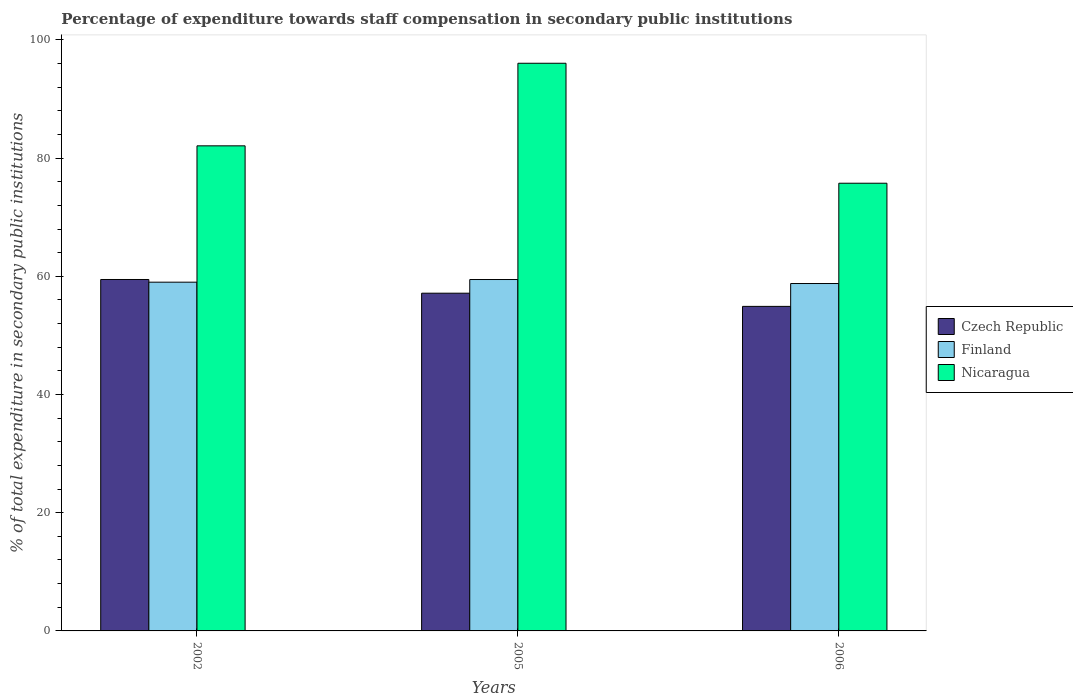How many different coloured bars are there?
Offer a terse response. 3. How many groups of bars are there?
Offer a very short reply. 3. Are the number of bars per tick equal to the number of legend labels?
Your answer should be compact. Yes. In how many cases, is the number of bars for a given year not equal to the number of legend labels?
Give a very brief answer. 0. What is the percentage of expenditure towards staff compensation in Nicaragua in 2005?
Provide a short and direct response. 96.04. Across all years, what is the maximum percentage of expenditure towards staff compensation in Nicaragua?
Ensure brevity in your answer.  96.04. Across all years, what is the minimum percentage of expenditure towards staff compensation in Czech Republic?
Keep it short and to the point. 54.91. In which year was the percentage of expenditure towards staff compensation in Czech Republic maximum?
Provide a short and direct response. 2002. In which year was the percentage of expenditure towards staff compensation in Nicaragua minimum?
Provide a short and direct response. 2006. What is the total percentage of expenditure towards staff compensation in Nicaragua in the graph?
Make the answer very short. 253.86. What is the difference between the percentage of expenditure towards staff compensation in Nicaragua in 2005 and that in 2006?
Make the answer very short. 20.3. What is the difference between the percentage of expenditure towards staff compensation in Finland in 2005 and the percentage of expenditure towards staff compensation in Czech Republic in 2002?
Your answer should be very brief. -0. What is the average percentage of expenditure towards staff compensation in Czech Republic per year?
Give a very brief answer. 57.17. In the year 2005, what is the difference between the percentage of expenditure towards staff compensation in Czech Republic and percentage of expenditure towards staff compensation in Finland?
Ensure brevity in your answer.  -2.31. What is the ratio of the percentage of expenditure towards staff compensation in Nicaragua in 2005 to that in 2006?
Your answer should be compact. 1.27. What is the difference between the highest and the second highest percentage of expenditure towards staff compensation in Finland?
Offer a terse response. 0.45. What is the difference between the highest and the lowest percentage of expenditure towards staff compensation in Finland?
Offer a terse response. 0.68. Is the sum of the percentage of expenditure towards staff compensation in Nicaragua in 2002 and 2006 greater than the maximum percentage of expenditure towards staff compensation in Finland across all years?
Offer a very short reply. Yes. Is it the case that in every year, the sum of the percentage of expenditure towards staff compensation in Nicaragua and percentage of expenditure towards staff compensation in Czech Republic is greater than the percentage of expenditure towards staff compensation in Finland?
Ensure brevity in your answer.  Yes. How many bars are there?
Keep it short and to the point. 9. Are all the bars in the graph horizontal?
Your response must be concise. No. How many years are there in the graph?
Give a very brief answer. 3. Are the values on the major ticks of Y-axis written in scientific E-notation?
Provide a succinct answer. No. Does the graph contain any zero values?
Your response must be concise. No. Where does the legend appear in the graph?
Your response must be concise. Center right. How are the legend labels stacked?
Ensure brevity in your answer.  Vertical. What is the title of the graph?
Ensure brevity in your answer.  Percentage of expenditure towards staff compensation in secondary public institutions. Does "Middle East & North Africa (developing only)" appear as one of the legend labels in the graph?
Make the answer very short. No. What is the label or title of the Y-axis?
Your answer should be compact. % of total expenditure in secondary public institutions. What is the % of total expenditure in secondary public institutions in Czech Republic in 2002?
Give a very brief answer. 59.46. What is the % of total expenditure in secondary public institutions of Finland in 2002?
Offer a very short reply. 59. What is the % of total expenditure in secondary public institutions of Nicaragua in 2002?
Provide a short and direct response. 82.07. What is the % of total expenditure in secondary public institutions of Czech Republic in 2005?
Your response must be concise. 57.14. What is the % of total expenditure in secondary public institutions in Finland in 2005?
Your answer should be compact. 59.45. What is the % of total expenditure in secondary public institutions of Nicaragua in 2005?
Give a very brief answer. 96.04. What is the % of total expenditure in secondary public institutions of Czech Republic in 2006?
Keep it short and to the point. 54.91. What is the % of total expenditure in secondary public institutions in Finland in 2006?
Offer a terse response. 58.78. What is the % of total expenditure in secondary public institutions of Nicaragua in 2006?
Offer a very short reply. 75.75. Across all years, what is the maximum % of total expenditure in secondary public institutions in Czech Republic?
Offer a very short reply. 59.46. Across all years, what is the maximum % of total expenditure in secondary public institutions of Finland?
Offer a terse response. 59.45. Across all years, what is the maximum % of total expenditure in secondary public institutions in Nicaragua?
Offer a terse response. 96.04. Across all years, what is the minimum % of total expenditure in secondary public institutions in Czech Republic?
Your response must be concise. 54.91. Across all years, what is the minimum % of total expenditure in secondary public institutions of Finland?
Keep it short and to the point. 58.78. Across all years, what is the minimum % of total expenditure in secondary public institutions of Nicaragua?
Your answer should be very brief. 75.75. What is the total % of total expenditure in secondary public institutions in Czech Republic in the graph?
Make the answer very short. 171.51. What is the total % of total expenditure in secondary public institutions in Finland in the graph?
Make the answer very short. 177.24. What is the total % of total expenditure in secondary public institutions of Nicaragua in the graph?
Your answer should be very brief. 253.86. What is the difference between the % of total expenditure in secondary public institutions in Czech Republic in 2002 and that in 2005?
Your answer should be compact. 2.32. What is the difference between the % of total expenditure in secondary public institutions of Finland in 2002 and that in 2005?
Offer a terse response. -0.45. What is the difference between the % of total expenditure in secondary public institutions of Nicaragua in 2002 and that in 2005?
Give a very brief answer. -13.97. What is the difference between the % of total expenditure in secondary public institutions in Czech Republic in 2002 and that in 2006?
Make the answer very short. 4.55. What is the difference between the % of total expenditure in secondary public institutions of Finland in 2002 and that in 2006?
Your response must be concise. 0.23. What is the difference between the % of total expenditure in secondary public institutions of Nicaragua in 2002 and that in 2006?
Provide a short and direct response. 6.33. What is the difference between the % of total expenditure in secondary public institutions in Czech Republic in 2005 and that in 2006?
Provide a short and direct response. 2.23. What is the difference between the % of total expenditure in secondary public institutions of Finland in 2005 and that in 2006?
Your answer should be compact. 0.68. What is the difference between the % of total expenditure in secondary public institutions of Nicaragua in 2005 and that in 2006?
Give a very brief answer. 20.3. What is the difference between the % of total expenditure in secondary public institutions in Czech Republic in 2002 and the % of total expenditure in secondary public institutions in Finland in 2005?
Your answer should be very brief. 0. What is the difference between the % of total expenditure in secondary public institutions in Czech Republic in 2002 and the % of total expenditure in secondary public institutions in Nicaragua in 2005?
Keep it short and to the point. -36.59. What is the difference between the % of total expenditure in secondary public institutions in Finland in 2002 and the % of total expenditure in secondary public institutions in Nicaragua in 2005?
Ensure brevity in your answer.  -37.04. What is the difference between the % of total expenditure in secondary public institutions of Czech Republic in 2002 and the % of total expenditure in secondary public institutions of Finland in 2006?
Your answer should be compact. 0.68. What is the difference between the % of total expenditure in secondary public institutions in Czech Republic in 2002 and the % of total expenditure in secondary public institutions in Nicaragua in 2006?
Make the answer very short. -16.29. What is the difference between the % of total expenditure in secondary public institutions in Finland in 2002 and the % of total expenditure in secondary public institutions in Nicaragua in 2006?
Provide a short and direct response. -16.74. What is the difference between the % of total expenditure in secondary public institutions of Czech Republic in 2005 and the % of total expenditure in secondary public institutions of Finland in 2006?
Your response must be concise. -1.64. What is the difference between the % of total expenditure in secondary public institutions in Czech Republic in 2005 and the % of total expenditure in secondary public institutions in Nicaragua in 2006?
Offer a terse response. -18.61. What is the difference between the % of total expenditure in secondary public institutions in Finland in 2005 and the % of total expenditure in secondary public institutions in Nicaragua in 2006?
Your answer should be very brief. -16.29. What is the average % of total expenditure in secondary public institutions in Czech Republic per year?
Make the answer very short. 57.17. What is the average % of total expenditure in secondary public institutions of Finland per year?
Make the answer very short. 59.08. What is the average % of total expenditure in secondary public institutions of Nicaragua per year?
Offer a terse response. 84.62. In the year 2002, what is the difference between the % of total expenditure in secondary public institutions of Czech Republic and % of total expenditure in secondary public institutions of Finland?
Keep it short and to the point. 0.45. In the year 2002, what is the difference between the % of total expenditure in secondary public institutions of Czech Republic and % of total expenditure in secondary public institutions of Nicaragua?
Your answer should be compact. -22.61. In the year 2002, what is the difference between the % of total expenditure in secondary public institutions of Finland and % of total expenditure in secondary public institutions of Nicaragua?
Offer a terse response. -23.07. In the year 2005, what is the difference between the % of total expenditure in secondary public institutions in Czech Republic and % of total expenditure in secondary public institutions in Finland?
Ensure brevity in your answer.  -2.31. In the year 2005, what is the difference between the % of total expenditure in secondary public institutions in Czech Republic and % of total expenditure in secondary public institutions in Nicaragua?
Offer a very short reply. -38.9. In the year 2005, what is the difference between the % of total expenditure in secondary public institutions of Finland and % of total expenditure in secondary public institutions of Nicaragua?
Provide a short and direct response. -36.59. In the year 2006, what is the difference between the % of total expenditure in secondary public institutions in Czech Republic and % of total expenditure in secondary public institutions in Finland?
Make the answer very short. -3.87. In the year 2006, what is the difference between the % of total expenditure in secondary public institutions of Czech Republic and % of total expenditure in secondary public institutions of Nicaragua?
Provide a short and direct response. -20.84. In the year 2006, what is the difference between the % of total expenditure in secondary public institutions in Finland and % of total expenditure in secondary public institutions in Nicaragua?
Give a very brief answer. -16.97. What is the ratio of the % of total expenditure in secondary public institutions in Czech Republic in 2002 to that in 2005?
Offer a terse response. 1.04. What is the ratio of the % of total expenditure in secondary public institutions in Nicaragua in 2002 to that in 2005?
Your answer should be very brief. 0.85. What is the ratio of the % of total expenditure in secondary public institutions of Czech Republic in 2002 to that in 2006?
Make the answer very short. 1.08. What is the ratio of the % of total expenditure in secondary public institutions of Nicaragua in 2002 to that in 2006?
Your answer should be compact. 1.08. What is the ratio of the % of total expenditure in secondary public institutions of Czech Republic in 2005 to that in 2006?
Provide a short and direct response. 1.04. What is the ratio of the % of total expenditure in secondary public institutions of Finland in 2005 to that in 2006?
Your answer should be compact. 1.01. What is the ratio of the % of total expenditure in secondary public institutions of Nicaragua in 2005 to that in 2006?
Keep it short and to the point. 1.27. What is the difference between the highest and the second highest % of total expenditure in secondary public institutions in Czech Republic?
Offer a very short reply. 2.32. What is the difference between the highest and the second highest % of total expenditure in secondary public institutions of Finland?
Your response must be concise. 0.45. What is the difference between the highest and the second highest % of total expenditure in secondary public institutions in Nicaragua?
Provide a succinct answer. 13.97. What is the difference between the highest and the lowest % of total expenditure in secondary public institutions of Czech Republic?
Ensure brevity in your answer.  4.55. What is the difference between the highest and the lowest % of total expenditure in secondary public institutions in Finland?
Make the answer very short. 0.68. What is the difference between the highest and the lowest % of total expenditure in secondary public institutions in Nicaragua?
Ensure brevity in your answer.  20.3. 